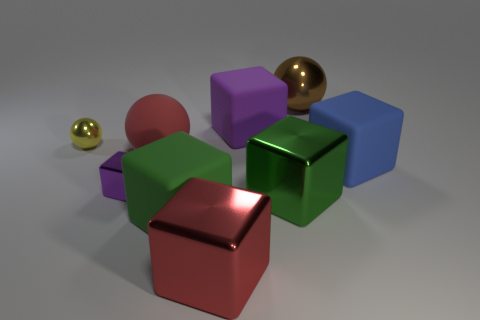How many other things are there of the same size as the brown sphere?
Make the answer very short. 6. There is a metal object behind the small yellow shiny thing; is its shape the same as the yellow object?
Give a very brief answer. Yes. How many other things are there of the same shape as the small purple shiny object?
Offer a terse response. 5. There is a purple thing that is in front of the blue rubber cube; what is its shape?
Provide a succinct answer. Cube. Is there a red sphere that has the same material as the large blue thing?
Provide a succinct answer. Yes. There is a rubber thing that is behind the red matte sphere; is it the same color as the small metal cube?
Offer a terse response. Yes. The yellow shiny ball is what size?
Your response must be concise. Small. There is a big green cube that is to the right of the large matte block that is in front of the small purple shiny object; are there any rubber things that are left of it?
Offer a terse response. Yes. There is a red sphere; how many rubber blocks are left of it?
Your answer should be compact. 0. What number of other tiny balls are the same color as the small metallic ball?
Give a very brief answer. 0. 